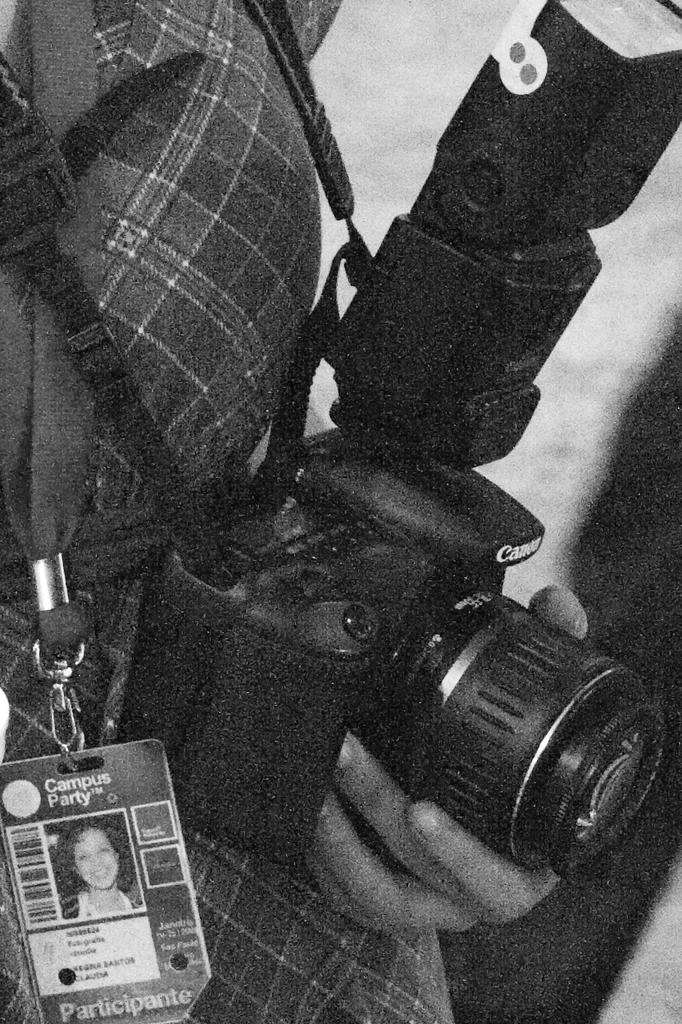What is the color scheme of the image? The image is black and white. What is the person in the image doing? The person is holding a camera in the image. Can you describe the person's appearance in the image? The person is partially covered. What other object is visible in the image? There is an ID card visible in the image. What is the ground like in the image? The ground is visible in the image. Is the person in the image stuck in quicksand? There is no indication of quicksand in the image, and the person is holding a camera, not struggling. 